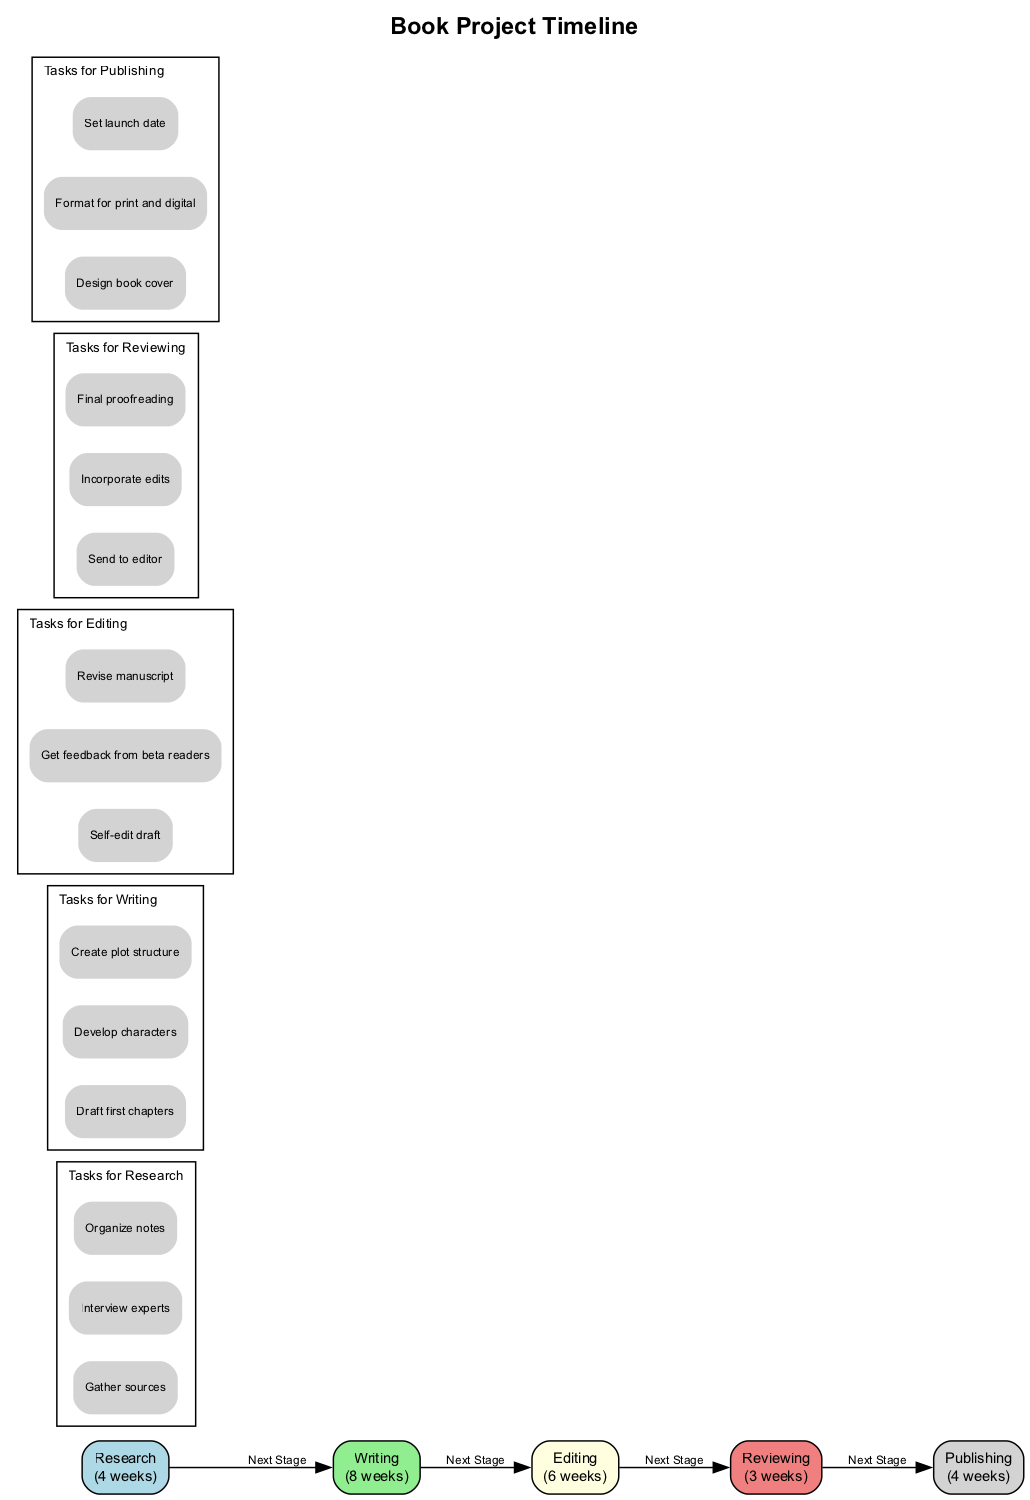What is the duration of the Editing stage? The duration of the Editing stage is explicitly stated in the diagram as "6 weeks."
Answer: 6 weeks How many total stages are in the diagram? By counting each of the stages listed—Research, Writing, Editing, Reviewing, and Publishing—there are a total of 5 stages presented in the diagram.
Answer: 5 Which stage has the lightgreen color code? The Writing stage is the one coded with lightgreen, as indicated by the color associated with that specific node in the diagram.
Answer: Writing What is the sequence of the final two stages in the timeline? The final two stages are Reviewing followed by Publishing, as the diagram connects these stages sequentially from one to the next.
Answer: Reviewing, Publishing What is the first task listed under Research? The first task under the Research stage is "Gather sources," which is displayed at the top of the list of tasks for this stage in the diagram.
Answer: Gather sources How long is the total time for the Writing stage compared to the Reviewing stage? The Writing stage lasts 8 weeks, while the Reviewing stage lasts 3 weeks. The comparison reveals that the Writing stage is 5 weeks longer than the Reviewing stage.
Answer: 5 weeks longer What tasks are included in the Editing stage? The tasks listed under the Editing stage are "Self-edit draft," "Get feedback from beta readers," and "Revise manuscript," all clearly outlined in the Tasks subgraph for Editing.
Answer: Self-edit draft, Get feedback from beta readers, Revise manuscript Which task comes last in the Publishing stage? The last task listed in the Publishing stage is "Set launch date," appearing as the final item in the task listing for this stage in the diagram.
Answer: Set launch date 